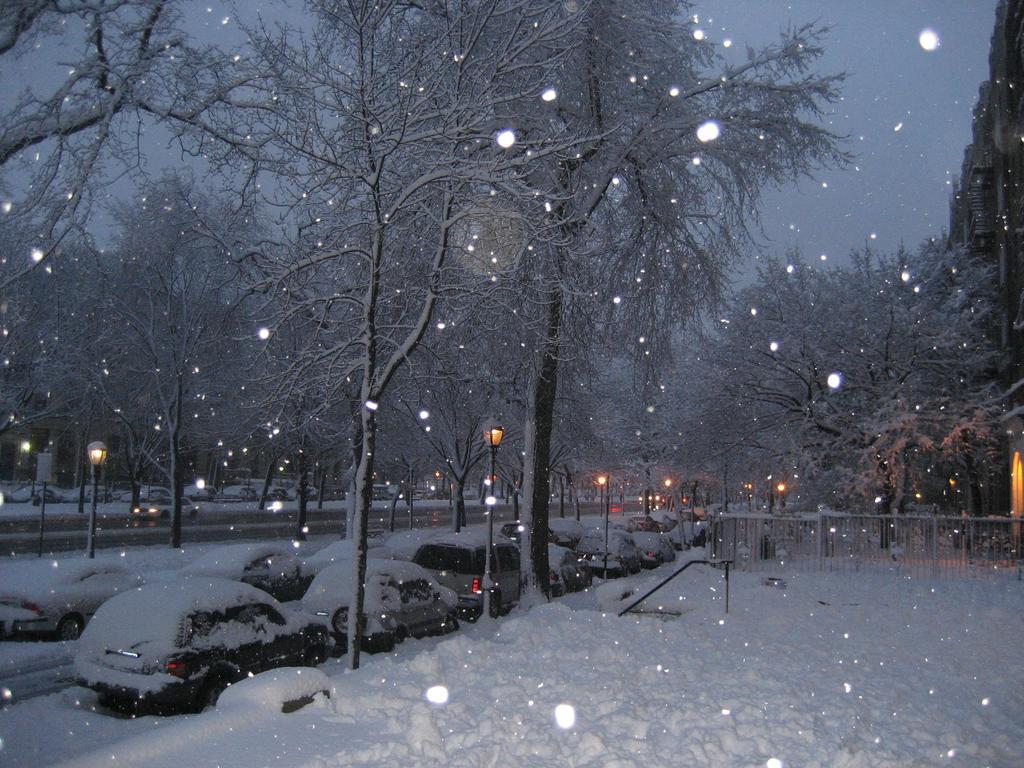What is the condition of the cars in the image? The cars are covered with snow in the image. What objects can be seen in the image besides the cars? There are poles, lights, a fence, trees, and the sky visible in the image. What might the poles be used for? The poles might be used for supporting lights or other objects. What type of vegetation is present in the image? There are trees in the image. What type of poison can be seen on the trees in the image? There is no poison present on the trees in the image; they are simply trees with no indication of any poisonous substances. 